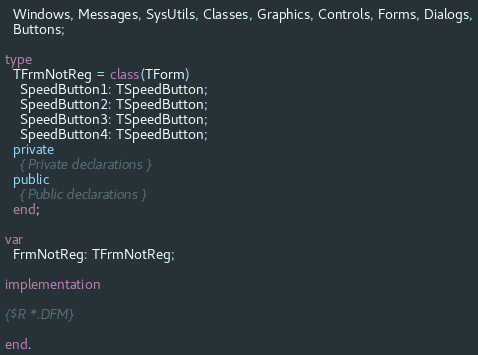Convert code to text. <code><loc_0><loc_0><loc_500><loc_500><_Pascal_>  Windows, Messages, SysUtils, Classes, Graphics, Controls, Forms, Dialogs,
  Buttons;

type
  TFrmNotReg = class(TForm)
    SpeedButton1: TSpeedButton;
    SpeedButton2: TSpeedButton;
    SpeedButton3: TSpeedButton;
    SpeedButton4: TSpeedButton;
  private
    { Private declarations }
  public
    { Public declarations }
  end;

var
  FrmNotReg: TFrmNotReg;

implementation

{$R *.DFM}

end.

</code> 